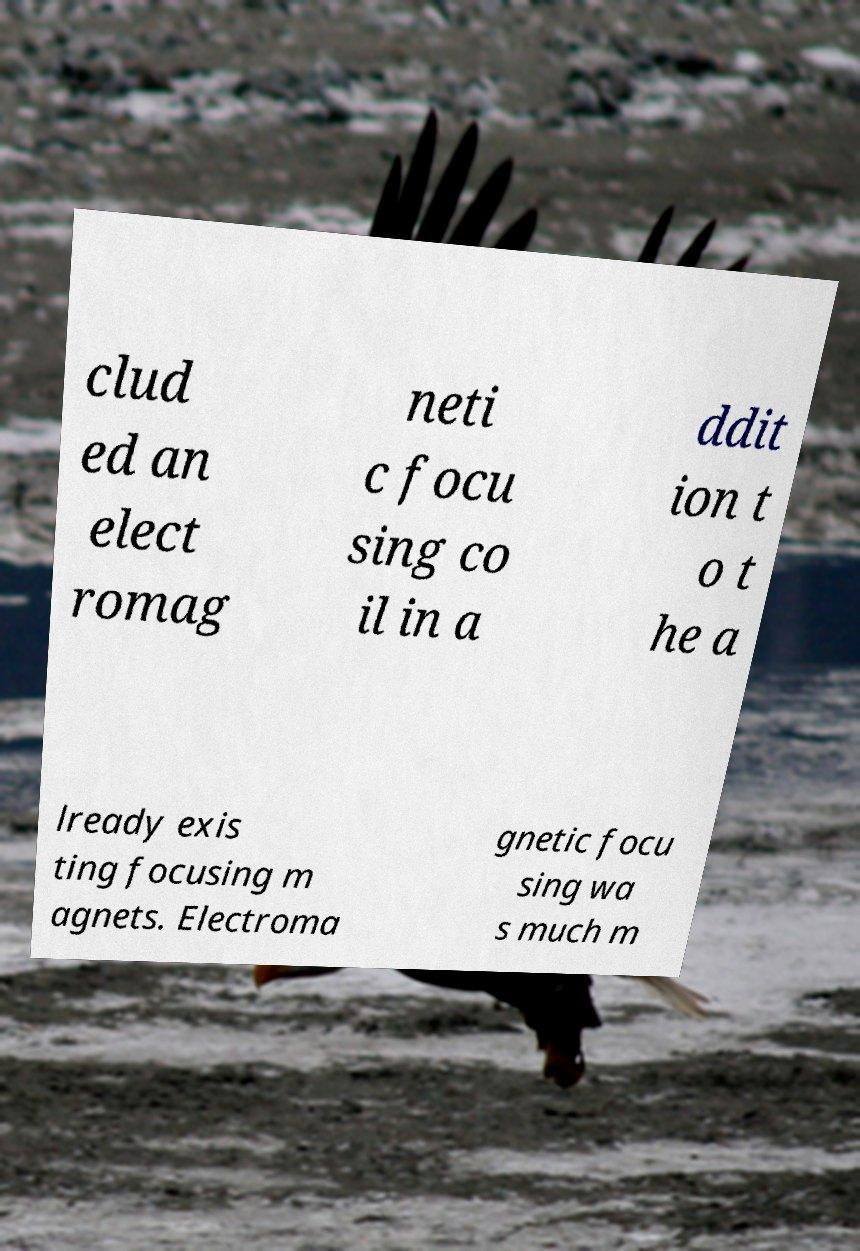Could you assist in decoding the text presented in this image and type it out clearly? clud ed an elect romag neti c focu sing co il in a ddit ion t o t he a lready exis ting focusing m agnets. Electroma gnetic focu sing wa s much m 